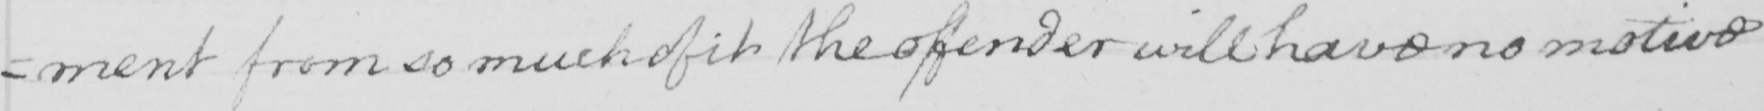What text is written in this handwritten line? =ment from so much of it the offender will have no motive 